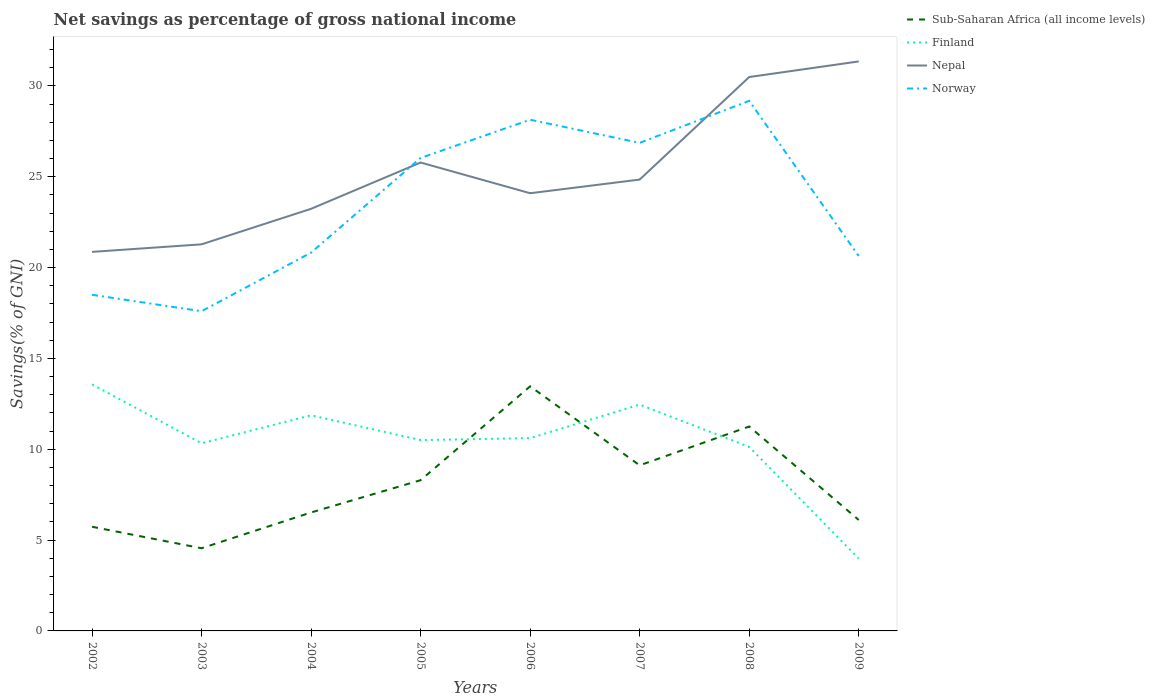Is the number of lines equal to the number of legend labels?
Your answer should be very brief. Yes. Across all years, what is the maximum total savings in Nepal?
Provide a short and direct response. 20.86. In which year was the total savings in Finland maximum?
Offer a very short reply. 2009. What is the total total savings in Nepal in the graph?
Offer a very short reply. -5.64. What is the difference between the highest and the second highest total savings in Finland?
Your response must be concise. 9.59. Is the total savings in Finland strictly greater than the total savings in Nepal over the years?
Provide a succinct answer. Yes. How many lines are there?
Your response must be concise. 4. Are the values on the major ticks of Y-axis written in scientific E-notation?
Offer a terse response. No. How many legend labels are there?
Provide a succinct answer. 4. How are the legend labels stacked?
Your response must be concise. Vertical. What is the title of the graph?
Give a very brief answer. Net savings as percentage of gross national income. What is the label or title of the X-axis?
Ensure brevity in your answer.  Years. What is the label or title of the Y-axis?
Offer a terse response. Savings(% of GNI). What is the Savings(% of GNI) in Sub-Saharan Africa (all income levels) in 2002?
Keep it short and to the point. 5.73. What is the Savings(% of GNI) in Finland in 2002?
Give a very brief answer. 13.57. What is the Savings(% of GNI) of Nepal in 2002?
Your response must be concise. 20.86. What is the Savings(% of GNI) of Norway in 2002?
Make the answer very short. 18.5. What is the Savings(% of GNI) of Sub-Saharan Africa (all income levels) in 2003?
Give a very brief answer. 4.55. What is the Savings(% of GNI) of Finland in 2003?
Offer a terse response. 10.33. What is the Savings(% of GNI) in Nepal in 2003?
Keep it short and to the point. 21.28. What is the Savings(% of GNI) of Norway in 2003?
Offer a very short reply. 17.6. What is the Savings(% of GNI) in Sub-Saharan Africa (all income levels) in 2004?
Ensure brevity in your answer.  6.52. What is the Savings(% of GNI) in Finland in 2004?
Ensure brevity in your answer.  11.87. What is the Savings(% of GNI) in Nepal in 2004?
Your response must be concise. 23.23. What is the Savings(% of GNI) of Norway in 2004?
Make the answer very short. 20.82. What is the Savings(% of GNI) of Sub-Saharan Africa (all income levels) in 2005?
Your answer should be compact. 8.3. What is the Savings(% of GNI) in Finland in 2005?
Offer a terse response. 10.5. What is the Savings(% of GNI) of Nepal in 2005?
Give a very brief answer. 25.78. What is the Savings(% of GNI) in Norway in 2005?
Your answer should be compact. 26.03. What is the Savings(% of GNI) of Sub-Saharan Africa (all income levels) in 2006?
Your response must be concise. 13.46. What is the Savings(% of GNI) in Finland in 2006?
Keep it short and to the point. 10.61. What is the Savings(% of GNI) in Nepal in 2006?
Offer a terse response. 24.09. What is the Savings(% of GNI) in Norway in 2006?
Provide a short and direct response. 28.14. What is the Savings(% of GNI) of Sub-Saharan Africa (all income levels) in 2007?
Your answer should be compact. 9.11. What is the Savings(% of GNI) in Finland in 2007?
Provide a succinct answer. 12.46. What is the Savings(% of GNI) of Nepal in 2007?
Keep it short and to the point. 24.84. What is the Savings(% of GNI) in Norway in 2007?
Ensure brevity in your answer.  26.86. What is the Savings(% of GNI) of Sub-Saharan Africa (all income levels) in 2008?
Offer a very short reply. 11.25. What is the Savings(% of GNI) in Finland in 2008?
Offer a terse response. 10.13. What is the Savings(% of GNI) in Nepal in 2008?
Offer a terse response. 30.49. What is the Savings(% of GNI) in Norway in 2008?
Your response must be concise. 29.18. What is the Savings(% of GNI) in Sub-Saharan Africa (all income levels) in 2009?
Make the answer very short. 6.11. What is the Savings(% of GNI) in Finland in 2009?
Provide a succinct answer. 3.99. What is the Savings(% of GNI) in Nepal in 2009?
Give a very brief answer. 31.35. What is the Savings(% of GNI) in Norway in 2009?
Provide a succinct answer. 20.64. Across all years, what is the maximum Savings(% of GNI) in Sub-Saharan Africa (all income levels)?
Your answer should be compact. 13.46. Across all years, what is the maximum Savings(% of GNI) in Finland?
Keep it short and to the point. 13.57. Across all years, what is the maximum Savings(% of GNI) of Nepal?
Offer a terse response. 31.35. Across all years, what is the maximum Savings(% of GNI) in Norway?
Make the answer very short. 29.18. Across all years, what is the minimum Savings(% of GNI) of Sub-Saharan Africa (all income levels)?
Give a very brief answer. 4.55. Across all years, what is the minimum Savings(% of GNI) of Finland?
Keep it short and to the point. 3.99. Across all years, what is the minimum Savings(% of GNI) in Nepal?
Ensure brevity in your answer.  20.86. Across all years, what is the minimum Savings(% of GNI) of Norway?
Keep it short and to the point. 17.6. What is the total Savings(% of GNI) in Sub-Saharan Africa (all income levels) in the graph?
Keep it short and to the point. 65.04. What is the total Savings(% of GNI) of Finland in the graph?
Your response must be concise. 83.46. What is the total Savings(% of GNI) of Nepal in the graph?
Your answer should be compact. 201.93. What is the total Savings(% of GNI) in Norway in the graph?
Your answer should be very brief. 187.77. What is the difference between the Savings(% of GNI) of Sub-Saharan Africa (all income levels) in 2002 and that in 2003?
Your answer should be compact. 1.18. What is the difference between the Savings(% of GNI) in Finland in 2002 and that in 2003?
Provide a succinct answer. 3.24. What is the difference between the Savings(% of GNI) of Nepal in 2002 and that in 2003?
Your response must be concise. -0.42. What is the difference between the Savings(% of GNI) in Norway in 2002 and that in 2003?
Offer a terse response. 0.9. What is the difference between the Savings(% of GNI) of Sub-Saharan Africa (all income levels) in 2002 and that in 2004?
Provide a succinct answer. -0.79. What is the difference between the Savings(% of GNI) of Finland in 2002 and that in 2004?
Offer a terse response. 1.7. What is the difference between the Savings(% of GNI) in Nepal in 2002 and that in 2004?
Give a very brief answer. -2.37. What is the difference between the Savings(% of GNI) in Norway in 2002 and that in 2004?
Ensure brevity in your answer.  -2.32. What is the difference between the Savings(% of GNI) in Sub-Saharan Africa (all income levels) in 2002 and that in 2005?
Give a very brief answer. -2.56. What is the difference between the Savings(% of GNI) in Finland in 2002 and that in 2005?
Keep it short and to the point. 3.07. What is the difference between the Savings(% of GNI) of Nepal in 2002 and that in 2005?
Offer a very short reply. -4.92. What is the difference between the Savings(% of GNI) in Norway in 2002 and that in 2005?
Make the answer very short. -7.53. What is the difference between the Savings(% of GNI) of Sub-Saharan Africa (all income levels) in 2002 and that in 2006?
Your answer should be very brief. -7.73. What is the difference between the Savings(% of GNI) in Finland in 2002 and that in 2006?
Offer a terse response. 2.96. What is the difference between the Savings(% of GNI) in Nepal in 2002 and that in 2006?
Ensure brevity in your answer.  -3.23. What is the difference between the Savings(% of GNI) in Norway in 2002 and that in 2006?
Keep it short and to the point. -9.64. What is the difference between the Savings(% of GNI) in Sub-Saharan Africa (all income levels) in 2002 and that in 2007?
Keep it short and to the point. -3.38. What is the difference between the Savings(% of GNI) of Finland in 2002 and that in 2007?
Offer a very short reply. 1.11. What is the difference between the Savings(% of GNI) of Nepal in 2002 and that in 2007?
Your response must be concise. -3.98. What is the difference between the Savings(% of GNI) in Norway in 2002 and that in 2007?
Your answer should be compact. -8.36. What is the difference between the Savings(% of GNI) of Sub-Saharan Africa (all income levels) in 2002 and that in 2008?
Your response must be concise. -5.52. What is the difference between the Savings(% of GNI) of Finland in 2002 and that in 2008?
Keep it short and to the point. 3.44. What is the difference between the Savings(% of GNI) in Nepal in 2002 and that in 2008?
Offer a very short reply. -9.62. What is the difference between the Savings(% of GNI) of Norway in 2002 and that in 2008?
Make the answer very short. -10.68. What is the difference between the Savings(% of GNI) in Sub-Saharan Africa (all income levels) in 2002 and that in 2009?
Give a very brief answer. -0.37. What is the difference between the Savings(% of GNI) of Finland in 2002 and that in 2009?
Make the answer very short. 9.59. What is the difference between the Savings(% of GNI) of Nepal in 2002 and that in 2009?
Your answer should be very brief. -10.48. What is the difference between the Savings(% of GNI) of Norway in 2002 and that in 2009?
Ensure brevity in your answer.  -2.14. What is the difference between the Savings(% of GNI) of Sub-Saharan Africa (all income levels) in 2003 and that in 2004?
Give a very brief answer. -1.97. What is the difference between the Savings(% of GNI) of Finland in 2003 and that in 2004?
Your answer should be very brief. -1.54. What is the difference between the Savings(% of GNI) of Nepal in 2003 and that in 2004?
Provide a short and direct response. -1.96. What is the difference between the Savings(% of GNI) in Norway in 2003 and that in 2004?
Your answer should be very brief. -3.23. What is the difference between the Savings(% of GNI) in Sub-Saharan Africa (all income levels) in 2003 and that in 2005?
Ensure brevity in your answer.  -3.75. What is the difference between the Savings(% of GNI) of Finland in 2003 and that in 2005?
Keep it short and to the point. -0.18. What is the difference between the Savings(% of GNI) of Nepal in 2003 and that in 2005?
Make the answer very short. -4.5. What is the difference between the Savings(% of GNI) in Norway in 2003 and that in 2005?
Offer a very short reply. -8.44. What is the difference between the Savings(% of GNI) of Sub-Saharan Africa (all income levels) in 2003 and that in 2006?
Provide a short and direct response. -8.91. What is the difference between the Savings(% of GNI) of Finland in 2003 and that in 2006?
Your response must be concise. -0.29. What is the difference between the Savings(% of GNI) in Nepal in 2003 and that in 2006?
Provide a short and direct response. -2.81. What is the difference between the Savings(% of GNI) in Norway in 2003 and that in 2006?
Your response must be concise. -10.54. What is the difference between the Savings(% of GNI) of Sub-Saharan Africa (all income levels) in 2003 and that in 2007?
Your response must be concise. -4.56. What is the difference between the Savings(% of GNI) in Finland in 2003 and that in 2007?
Keep it short and to the point. -2.13. What is the difference between the Savings(% of GNI) of Nepal in 2003 and that in 2007?
Offer a terse response. -3.57. What is the difference between the Savings(% of GNI) of Norway in 2003 and that in 2007?
Give a very brief answer. -9.27. What is the difference between the Savings(% of GNI) in Sub-Saharan Africa (all income levels) in 2003 and that in 2008?
Offer a very short reply. -6.7. What is the difference between the Savings(% of GNI) of Finland in 2003 and that in 2008?
Ensure brevity in your answer.  0.2. What is the difference between the Savings(% of GNI) of Nepal in 2003 and that in 2008?
Offer a terse response. -9.21. What is the difference between the Savings(% of GNI) in Norway in 2003 and that in 2008?
Make the answer very short. -11.58. What is the difference between the Savings(% of GNI) in Sub-Saharan Africa (all income levels) in 2003 and that in 2009?
Provide a short and direct response. -1.56. What is the difference between the Savings(% of GNI) in Finland in 2003 and that in 2009?
Give a very brief answer. 6.34. What is the difference between the Savings(% of GNI) of Nepal in 2003 and that in 2009?
Make the answer very short. -10.07. What is the difference between the Savings(% of GNI) in Norway in 2003 and that in 2009?
Offer a very short reply. -3.04. What is the difference between the Savings(% of GNI) in Sub-Saharan Africa (all income levels) in 2004 and that in 2005?
Keep it short and to the point. -1.78. What is the difference between the Savings(% of GNI) in Finland in 2004 and that in 2005?
Offer a terse response. 1.36. What is the difference between the Savings(% of GNI) in Nepal in 2004 and that in 2005?
Offer a terse response. -2.55. What is the difference between the Savings(% of GNI) of Norway in 2004 and that in 2005?
Offer a very short reply. -5.21. What is the difference between the Savings(% of GNI) in Sub-Saharan Africa (all income levels) in 2004 and that in 2006?
Ensure brevity in your answer.  -6.94. What is the difference between the Savings(% of GNI) in Finland in 2004 and that in 2006?
Your response must be concise. 1.26. What is the difference between the Savings(% of GNI) in Nepal in 2004 and that in 2006?
Offer a terse response. -0.86. What is the difference between the Savings(% of GNI) in Norway in 2004 and that in 2006?
Offer a terse response. -7.31. What is the difference between the Savings(% of GNI) of Sub-Saharan Africa (all income levels) in 2004 and that in 2007?
Make the answer very short. -2.59. What is the difference between the Savings(% of GNI) of Finland in 2004 and that in 2007?
Provide a short and direct response. -0.59. What is the difference between the Savings(% of GNI) of Nepal in 2004 and that in 2007?
Ensure brevity in your answer.  -1.61. What is the difference between the Savings(% of GNI) of Norway in 2004 and that in 2007?
Offer a very short reply. -6.04. What is the difference between the Savings(% of GNI) in Sub-Saharan Africa (all income levels) in 2004 and that in 2008?
Offer a very short reply. -4.73. What is the difference between the Savings(% of GNI) in Finland in 2004 and that in 2008?
Make the answer very short. 1.74. What is the difference between the Savings(% of GNI) in Nepal in 2004 and that in 2008?
Offer a very short reply. -7.25. What is the difference between the Savings(% of GNI) in Norway in 2004 and that in 2008?
Your response must be concise. -8.36. What is the difference between the Savings(% of GNI) in Sub-Saharan Africa (all income levels) in 2004 and that in 2009?
Provide a succinct answer. 0.41. What is the difference between the Savings(% of GNI) of Finland in 2004 and that in 2009?
Ensure brevity in your answer.  7.88. What is the difference between the Savings(% of GNI) in Nepal in 2004 and that in 2009?
Your answer should be very brief. -8.11. What is the difference between the Savings(% of GNI) in Norway in 2004 and that in 2009?
Give a very brief answer. 0.19. What is the difference between the Savings(% of GNI) in Sub-Saharan Africa (all income levels) in 2005 and that in 2006?
Your response must be concise. -5.17. What is the difference between the Savings(% of GNI) of Finland in 2005 and that in 2006?
Provide a short and direct response. -0.11. What is the difference between the Savings(% of GNI) in Nepal in 2005 and that in 2006?
Your answer should be compact. 1.69. What is the difference between the Savings(% of GNI) of Norway in 2005 and that in 2006?
Keep it short and to the point. -2.1. What is the difference between the Savings(% of GNI) in Sub-Saharan Africa (all income levels) in 2005 and that in 2007?
Offer a terse response. -0.82. What is the difference between the Savings(% of GNI) in Finland in 2005 and that in 2007?
Your answer should be compact. -1.95. What is the difference between the Savings(% of GNI) of Nepal in 2005 and that in 2007?
Provide a succinct answer. 0.94. What is the difference between the Savings(% of GNI) of Norway in 2005 and that in 2007?
Offer a very short reply. -0.83. What is the difference between the Savings(% of GNI) of Sub-Saharan Africa (all income levels) in 2005 and that in 2008?
Offer a very short reply. -2.95. What is the difference between the Savings(% of GNI) in Finland in 2005 and that in 2008?
Your answer should be very brief. 0.38. What is the difference between the Savings(% of GNI) of Nepal in 2005 and that in 2008?
Provide a short and direct response. -4.71. What is the difference between the Savings(% of GNI) in Norway in 2005 and that in 2008?
Your response must be concise. -3.14. What is the difference between the Savings(% of GNI) of Sub-Saharan Africa (all income levels) in 2005 and that in 2009?
Keep it short and to the point. 2.19. What is the difference between the Savings(% of GNI) in Finland in 2005 and that in 2009?
Offer a very short reply. 6.52. What is the difference between the Savings(% of GNI) in Nepal in 2005 and that in 2009?
Your answer should be compact. -5.56. What is the difference between the Savings(% of GNI) in Norway in 2005 and that in 2009?
Give a very brief answer. 5.4. What is the difference between the Savings(% of GNI) of Sub-Saharan Africa (all income levels) in 2006 and that in 2007?
Keep it short and to the point. 4.35. What is the difference between the Savings(% of GNI) of Finland in 2006 and that in 2007?
Provide a short and direct response. -1.85. What is the difference between the Savings(% of GNI) of Nepal in 2006 and that in 2007?
Offer a terse response. -0.75. What is the difference between the Savings(% of GNI) of Norway in 2006 and that in 2007?
Make the answer very short. 1.27. What is the difference between the Savings(% of GNI) of Sub-Saharan Africa (all income levels) in 2006 and that in 2008?
Make the answer very short. 2.21. What is the difference between the Savings(% of GNI) of Finland in 2006 and that in 2008?
Keep it short and to the point. 0.48. What is the difference between the Savings(% of GNI) in Nepal in 2006 and that in 2008?
Make the answer very short. -6.4. What is the difference between the Savings(% of GNI) in Norway in 2006 and that in 2008?
Give a very brief answer. -1.04. What is the difference between the Savings(% of GNI) of Sub-Saharan Africa (all income levels) in 2006 and that in 2009?
Offer a terse response. 7.36. What is the difference between the Savings(% of GNI) of Finland in 2006 and that in 2009?
Give a very brief answer. 6.63. What is the difference between the Savings(% of GNI) of Nepal in 2006 and that in 2009?
Your answer should be compact. -7.25. What is the difference between the Savings(% of GNI) of Norway in 2006 and that in 2009?
Keep it short and to the point. 7.5. What is the difference between the Savings(% of GNI) in Sub-Saharan Africa (all income levels) in 2007 and that in 2008?
Offer a very short reply. -2.14. What is the difference between the Savings(% of GNI) in Finland in 2007 and that in 2008?
Your response must be concise. 2.33. What is the difference between the Savings(% of GNI) in Nepal in 2007 and that in 2008?
Your response must be concise. -5.64. What is the difference between the Savings(% of GNI) in Norway in 2007 and that in 2008?
Your answer should be very brief. -2.31. What is the difference between the Savings(% of GNI) of Sub-Saharan Africa (all income levels) in 2007 and that in 2009?
Your answer should be compact. 3.01. What is the difference between the Savings(% of GNI) in Finland in 2007 and that in 2009?
Give a very brief answer. 8.47. What is the difference between the Savings(% of GNI) of Nepal in 2007 and that in 2009?
Give a very brief answer. -6.5. What is the difference between the Savings(% of GNI) in Norway in 2007 and that in 2009?
Offer a very short reply. 6.23. What is the difference between the Savings(% of GNI) in Sub-Saharan Africa (all income levels) in 2008 and that in 2009?
Offer a terse response. 5.14. What is the difference between the Savings(% of GNI) in Finland in 2008 and that in 2009?
Ensure brevity in your answer.  6.14. What is the difference between the Savings(% of GNI) in Nepal in 2008 and that in 2009?
Make the answer very short. -0.86. What is the difference between the Savings(% of GNI) of Norway in 2008 and that in 2009?
Your answer should be very brief. 8.54. What is the difference between the Savings(% of GNI) in Sub-Saharan Africa (all income levels) in 2002 and the Savings(% of GNI) in Finland in 2003?
Offer a terse response. -4.59. What is the difference between the Savings(% of GNI) in Sub-Saharan Africa (all income levels) in 2002 and the Savings(% of GNI) in Nepal in 2003?
Your answer should be compact. -15.55. What is the difference between the Savings(% of GNI) in Sub-Saharan Africa (all income levels) in 2002 and the Savings(% of GNI) in Norway in 2003?
Give a very brief answer. -11.86. What is the difference between the Savings(% of GNI) of Finland in 2002 and the Savings(% of GNI) of Nepal in 2003?
Keep it short and to the point. -7.71. What is the difference between the Savings(% of GNI) in Finland in 2002 and the Savings(% of GNI) in Norway in 2003?
Your response must be concise. -4.03. What is the difference between the Savings(% of GNI) of Nepal in 2002 and the Savings(% of GNI) of Norway in 2003?
Ensure brevity in your answer.  3.27. What is the difference between the Savings(% of GNI) in Sub-Saharan Africa (all income levels) in 2002 and the Savings(% of GNI) in Finland in 2004?
Your answer should be very brief. -6.14. What is the difference between the Savings(% of GNI) in Sub-Saharan Africa (all income levels) in 2002 and the Savings(% of GNI) in Nepal in 2004?
Your answer should be compact. -17.5. What is the difference between the Savings(% of GNI) of Sub-Saharan Africa (all income levels) in 2002 and the Savings(% of GNI) of Norway in 2004?
Your answer should be compact. -15.09. What is the difference between the Savings(% of GNI) in Finland in 2002 and the Savings(% of GNI) in Nepal in 2004?
Offer a very short reply. -9.66. What is the difference between the Savings(% of GNI) of Finland in 2002 and the Savings(% of GNI) of Norway in 2004?
Provide a succinct answer. -7.25. What is the difference between the Savings(% of GNI) in Nepal in 2002 and the Savings(% of GNI) in Norway in 2004?
Your answer should be very brief. 0.04. What is the difference between the Savings(% of GNI) of Sub-Saharan Africa (all income levels) in 2002 and the Savings(% of GNI) of Finland in 2005?
Your answer should be compact. -4.77. What is the difference between the Savings(% of GNI) of Sub-Saharan Africa (all income levels) in 2002 and the Savings(% of GNI) of Nepal in 2005?
Give a very brief answer. -20.05. What is the difference between the Savings(% of GNI) in Sub-Saharan Africa (all income levels) in 2002 and the Savings(% of GNI) in Norway in 2005?
Give a very brief answer. -20.3. What is the difference between the Savings(% of GNI) in Finland in 2002 and the Savings(% of GNI) in Nepal in 2005?
Make the answer very short. -12.21. What is the difference between the Savings(% of GNI) of Finland in 2002 and the Savings(% of GNI) of Norway in 2005?
Make the answer very short. -12.46. What is the difference between the Savings(% of GNI) in Nepal in 2002 and the Savings(% of GNI) in Norway in 2005?
Your answer should be very brief. -5.17. What is the difference between the Savings(% of GNI) in Sub-Saharan Africa (all income levels) in 2002 and the Savings(% of GNI) in Finland in 2006?
Offer a very short reply. -4.88. What is the difference between the Savings(% of GNI) of Sub-Saharan Africa (all income levels) in 2002 and the Savings(% of GNI) of Nepal in 2006?
Keep it short and to the point. -18.36. What is the difference between the Savings(% of GNI) in Sub-Saharan Africa (all income levels) in 2002 and the Savings(% of GNI) in Norway in 2006?
Give a very brief answer. -22.4. What is the difference between the Savings(% of GNI) in Finland in 2002 and the Savings(% of GNI) in Nepal in 2006?
Offer a very short reply. -10.52. What is the difference between the Savings(% of GNI) in Finland in 2002 and the Savings(% of GNI) in Norway in 2006?
Your answer should be compact. -14.57. What is the difference between the Savings(% of GNI) in Nepal in 2002 and the Savings(% of GNI) in Norway in 2006?
Offer a terse response. -7.27. What is the difference between the Savings(% of GNI) of Sub-Saharan Africa (all income levels) in 2002 and the Savings(% of GNI) of Finland in 2007?
Your answer should be compact. -6.73. What is the difference between the Savings(% of GNI) of Sub-Saharan Africa (all income levels) in 2002 and the Savings(% of GNI) of Nepal in 2007?
Keep it short and to the point. -19.11. What is the difference between the Savings(% of GNI) of Sub-Saharan Africa (all income levels) in 2002 and the Savings(% of GNI) of Norway in 2007?
Your answer should be compact. -21.13. What is the difference between the Savings(% of GNI) in Finland in 2002 and the Savings(% of GNI) in Nepal in 2007?
Ensure brevity in your answer.  -11.27. What is the difference between the Savings(% of GNI) of Finland in 2002 and the Savings(% of GNI) of Norway in 2007?
Offer a very short reply. -13.29. What is the difference between the Savings(% of GNI) of Nepal in 2002 and the Savings(% of GNI) of Norway in 2007?
Offer a very short reply. -6. What is the difference between the Savings(% of GNI) in Sub-Saharan Africa (all income levels) in 2002 and the Savings(% of GNI) in Finland in 2008?
Your answer should be compact. -4.4. What is the difference between the Savings(% of GNI) of Sub-Saharan Africa (all income levels) in 2002 and the Savings(% of GNI) of Nepal in 2008?
Give a very brief answer. -24.76. What is the difference between the Savings(% of GNI) of Sub-Saharan Africa (all income levels) in 2002 and the Savings(% of GNI) of Norway in 2008?
Provide a succinct answer. -23.45. What is the difference between the Savings(% of GNI) of Finland in 2002 and the Savings(% of GNI) of Nepal in 2008?
Make the answer very short. -16.92. What is the difference between the Savings(% of GNI) in Finland in 2002 and the Savings(% of GNI) in Norway in 2008?
Provide a short and direct response. -15.61. What is the difference between the Savings(% of GNI) in Nepal in 2002 and the Savings(% of GNI) in Norway in 2008?
Offer a terse response. -8.32. What is the difference between the Savings(% of GNI) of Sub-Saharan Africa (all income levels) in 2002 and the Savings(% of GNI) of Finland in 2009?
Your answer should be very brief. 1.75. What is the difference between the Savings(% of GNI) of Sub-Saharan Africa (all income levels) in 2002 and the Savings(% of GNI) of Nepal in 2009?
Your answer should be very brief. -25.61. What is the difference between the Savings(% of GNI) in Sub-Saharan Africa (all income levels) in 2002 and the Savings(% of GNI) in Norway in 2009?
Make the answer very short. -14.9. What is the difference between the Savings(% of GNI) in Finland in 2002 and the Savings(% of GNI) in Nepal in 2009?
Make the answer very short. -17.78. What is the difference between the Savings(% of GNI) in Finland in 2002 and the Savings(% of GNI) in Norway in 2009?
Offer a terse response. -7.07. What is the difference between the Savings(% of GNI) of Nepal in 2002 and the Savings(% of GNI) of Norway in 2009?
Offer a terse response. 0.23. What is the difference between the Savings(% of GNI) of Sub-Saharan Africa (all income levels) in 2003 and the Savings(% of GNI) of Finland in 2004?
Provide a succinct answer. -7.32. What is the difference between the Savings(% of GNI) in Sub-Saharan Africa (all income levels) in 2003 and the Savings(% of GNI) in Nepal in 2004?
Your answer should be compact. -18.68. What is the difference between the Savings(% of GNI) of Sub-Saharan Africa (all income levels) in 2003 and the Savings(% of GNI) of Norway in 2004?
Your answer should be very brief. -16.27. What is the difference between the Savings(% of GNI) in Finland in 2003 and the Savings(% of GNI) in Nepal in 2004?
Your answer should be very brief. -12.91. What is the difference between the Savings(% of GNI) of Finland in 2003 and the Savings(% of GNI) of Norway in 2004?
Give a very brief answer. -10.5. What is the difference between the Savings(% of GNI) of Nepal in 2003 and the Savings(% of GNI) of Norway in 2004?
Offer a terse response. 0.46. What is the difference between the Savings(% of GNI) in Sub-Saharan Africa (all income levels) in 2003 and the Savings(% of GNI) in Finland in 2005?
Your answer should be compact. -5.95. What is the difference between the Savings(% of GNI) of Sub-Saharan Africa (all income levels) in 2003 and the Savings(% of GNI) of Nepal in 2005?
Ensure brevity in your answer.  -21.23. What is the difference between the Savings(% of GNI) in Sub-Saharan Africa (all income levels) in 2003 and the Savings(% of GNI) in Norway in 2005?
Ensure brevity in your answer.  -21.48. What is the difference between the Savings(% of GNI) of Finland in 2003 and the Savings(% of GNI) of Nepal in 2005?
Give a very brief answer. -15.45. What is the difference between the Savings(% of GNI) of Finland in 2003 and the Savings(% of GNI) of Norway in 2005?
Make the answer very short. -15.71. What is the difference between the Savings(% of GNI) of Nepal in 2003 and the Savings(% of GNI) of Norway in 2005?
Offer a very short reply. -4.76. What is the difference between the Savings(% of GNI) in Sub-Saharan Africa (all income levels) in 2003 and the Savings(% of GNI) in Finland in 2006?
Provide a short and direct response. -6.06. What is the difference between the Savings(% of GNI) in Sub-Saharan Africa (all income levels) in 2003 and the Savings(% of GNI) in Nepal in 2006?
Make the answer very short. -19.54. What is the difference between the Savings(% of GNI) in Sub-Saharan Africa (all income levels) in 2003 and the Savings(% of GNI) in Norway in 2006?
Make the answer very short. -23.59. What is the difference between the Savings(% of GNI) in Finland in 2003 and the Savings(% of GNI) in Nepal in 2006?
Your answer should be compact. -13.77. What is the difference between the Savings(% of GNI) in Finland in 2003 and the Savings(% of GNI) in Norway in 2006?
Offer a very short reply. -17.81. What is the difference between the Savings(% of GNI) in Nepal in 2003 and the Savings(% of GNI) in Norway in 2006?
Provide a succinct answer. -6.86. What is the difference between the Savings(% of GNI) of Sub-Saharan Africa (all income levels) in 2003 and the Savings(% of GNI) of Finland in 2007?
Offer a very short reply. -7.91. What is the difference between the Savings(% of GNI) in Sub-Saharan Africa (all income levels) in 2003 and the Savings(% of GNI) in Nepal in 2007?
Ensure brevity in your answer.  -20.29. What is the difference between the Savings(% of GNI) in Sub-Saharan Africa (all income levels) in 2003 and the Savings(% of GNI) in Norway in 2007?
Make the answer very short. -22.31. What is the difference between the Savings(% of GNI) of Finland in 2003 and the Savings(% of GNI) of Nepal in 2007?
Provide a short and direct response. -14.52. What is the difference between the Savings(% of GNI) of Finland in 2003 and the Savings(% of GNI) of Norway in 2007?
Offer a terse response. -16.54. What is the difference between the Savings(% of GNI) in Nepal in 2003 and the Savings(% of GNI) in Norway in 2007?
Make the answer very short. -5.59. What is the difference between the Savings(% of GNI) of Sub-Saharan Africa (all income levels) in 2003 and the Savings(% of GNI) of Finland in 2008?
Offer a terse response. -5.58. What is the difference between the Savings(% of GNI) in Sub-Saharan Africa (all income levels) in 2003 and the Savings(% of GNI) in Nepal in 2008?
Provide a succinct answer. -25.94. What is the difference between the Savings(% of GNI) of Sub-Saharan Africa (all income levels) in 2003 and the Savings(% of GNI) of Norway in 2008?
Make the answer very short. -24.63. What is the difference between the Savings(% of GNI) of Finland in 2003 and the Savings(% of GNI) of Nepal in 2008?
Your answer should be compact. -20.16. What is the difference between the Savings(% of GNI) of Finland in 2003 and the Savings(% of GNI) of Norway in 2008?
Give a very brief answer. -18.85. What is the difference between the Savings(% of GNI) of Nepal in 2003 and the Savings(% of GNI) of Norway in 2008?
Ensure brevity in your answer.  -7.9. What is the difference between the Savings(% of GNI) of Sub-Saharan Africa (all income levels) in 2003 and the Savings(% of GNI) of Finland in 2009?
Offer a terse response. 0.57. What is the difference between the Savings(% of GNI) in Sub-Saharan Africa (all income levels) in 2003 and the Savings(% of GNI) in Nepal in 2009?
Give a very brief answer. -26.8. What is the difference between the Savings(% of GNI) of Sub-Saharan Africa (all income levels) in 2003 and the Savings(% of GNI) of Norway in 2009?
Offer a very short reply. -16.09. What is the difference between the Savings(% of GNI) of Finland in 2003 and the Savings(% of GNI) of Nepal in 2009?
Offer a very short reply. -21.02. What is the difference between the Savings(% of GNI) of Finland in 2003 and the Savings(% of GNI) of Norway in 2009?
Your response must be concise. -10.31. What is the difference between the Savings(% of GNI) in Nepal in 2003 and the Savings(% of GNI) in Norway in 2009?
Give a very brief answer. 0.64. What is the difference between the Savings(% of GNI) of Sub-Saharan Africa (all income levels) in 2004 and the Savings(% of GNI) of Finland in 2005?
Provide a succinct answer. -3.98. What is the difference between the Savings(% of GNI) of Sub-Saharan Africa (all income levels) in 2004 and the Savings(% of GNI) of Nepal in 2005?
Your response must be concise. -19.26. What is the difference between the Savings(% of GNI) of Sub-Saharan Africa (all income levels) in 2004 and the Savings(% of GNI) of Norway in 2005?
Provide a short and direct response. -19.51. What is the difference between the Savings(% of GNI) of Finland in 2004 and the Savings(% of GNI) of Nepal in 2005?
Your answer should be compact. -13.91. What is the difference between the Savings(% of GNI) of Finland in 2004 and the Savings(% of GNI) of Norway in 2005?
Offer a terse response. -14.16. What is the difference between the Savings(% of GNI) of Nepal in 2004 and the Savings(% of GNI) of Norway in 2005?
Offer a terse response. -2.8. What is the difference between the Savings(% of GNI) in Sub-Saharan Africa (all income levels) in 2004 and the Savings(% of GNI) in Finland in 2006?
Your response must be concise. -4.09. What is the difference between the Savings(% of GNI) in Sub-Saharan Africa (all income levels) in 2004 and the Savings(% of GNI) in Nepal in 2006?
Provide a succinct answer. -17.57. What is the difference between the Savings(% of GNI) in Sub-Saharan Africa (all income levels) in 2004 and the Savings(% of GNI) in Norway in 2006?
Ensure brevity in your answer.  -21.62. What is the difference between the Savings(% of GNI) in Finland in 2004 and the Savings(% of GNI) in Nepal in 2006?
Your answer should be compact. -12.22. What is the difference between the Savings(% of GNI) in Finland in 2004 and the Savings(% of GNI) in Norway in 2006?
Provide a succinct answer. -16.27. What is the difference between the Savings(% of GNI) of Nepal in 2004 and the Savings(% of GNI) of Norway in 2006?
Offer a very short reply. -4.9. What is the difference between the Savings(% of GNI) in Sub-Saharan Africa (all income levels) in 2004 and the Savings(% of GNI) in Finland in 2007?
Your answer should be very brief. -5.94. What is the difference between the Savings(% of GNI) of Sub-Saharan Africa (all income levels) in 2004 and the Savings(% of GNI) of Nepal in 2007?
Keep it short and to the point. -18.32. What is the difference between the Savings(% of GNI) in Sub-Saharan Africa (all income levels) in 2004 and the Savings(% of GNI) in Norway in 2007?
Offer a very short reply. -20.34. What is the difference between the Savings(% of GNI) in Finland in 2004 and the Savings(% of GNI) in Nepal in 2007?
Give a very brief answer. -12.97. What is the difference between the Savings(% of GNI) in Finland in 2004 and the Savings(% of GNI) in Norway in 2007?
Offer a very short reply. -14.99. What is the difference between the Savings(% of GNI) of Nepal in 2004 and the Savings(% of GNI) of Norway in 2007?
Ensure brevity in your answer.  -3.63. What is the difference between the Savings(% of GNI) in Sub-Saharan Africa (all income levels) in 2004 and the Savings(% of GNI) in Finland in 2008?
Offer a terse response. -3.61. What is the difference between the Savings(% of GNI) of Sub-Saharan Africa (all income levels) in 2004 and the Savings(% of GNI) of Nepal in 2008?
Keep it short and to the point. -23.97. What is the difference between the Savings(% of GNI) in Sub-Saharan Africa (all income levels) in 2004 and the Savings(% of GNI) in Norway in 2008?
Offer a terse response. -22.66. What is the difference between the Savings(% of GNI) in Finland in 2004 and the Savings(% of GNI) in Nepal in 2008?
Your answer should be compact. -18.62. What is the difference between the Savings(% of GNI) in Finland in 2004 and the Savings(% of GNI) in Norway in 2008?
Offer a very short reply. -17.31. What is the difference between the Savings(% of GNI) in Nepal in 2004 and the Savings(% of GNI) in Norway in 2008?
Your response must be concise. -5.94. What is the difference between the Savings(% of GNI) of Sub-Saharan Africa (all income levels) in 2004 and the Savings(% of GNI) of Finland in 2009?
Provide a succinct answer. 2.54. What is the difference between the Savings(% of GNI) of Sub-Saharan Africa (all income levels) in 2004 and the Savings(% of GNI) of Nepal in 2009?
Offer a very short reply. -24.83. What is the difference between the Savings(% of GNI) of Sub-Saharan Africa (all income levels) in 2004 and the Savings(% of GNI) of Norway in 2009?
Make the answer very short. -14.12. What is the difference between the Savings(% of GNI) of Finland in 2004 and the Savings(% of GNI) of Nepal in 2009?
Provide a short and direct response. -19.48. What is the difference between the Savings(% of GNI) in Finland in 2004 and the Savings(% of GNI) in Norway in 2009?
Your answer should be very brief. -8.77. What is the difference between the Savings(% of GNI) of Nepal in 2004 and the Savings(% of GNI) of Norway in 2009?
Provide a succinct answer. 2.6. What is the difference between the Savings(% of GNI) of Sub-Saharan Africa (all income levels) in 2005 and the Savings(% of GNI) of Finland in 2006?
Your answer should be compact. -2.32. What is the difference between the Savings(% of GNI) in Sub-Saharan Africa (all income levels) in 2005 and the Savings(% of GNI) in Nepal in 2006?
Offer a very short reply. -15.8. What is the difference between the Savings(% of GNI) in Sub-Saharan Africa (all income levels) in 2005 and the Savings(% of GNI) in Norway in 2006?
Your answer should be compact. -19.84. What is the difference between the Savings(% of GNI) in Finland in 2005 and the Savings(% of GNI) in Nepal in 2006?
Your answer should be compact. -13.59. What is the difference between the Savings(% of GNI) in Finland in 2005 and the Savings(% of GNI) in Norway in 2006?
Your answer should be compact. -17.63. What is the difference between the Savings(% of GNI) in Nepal in 2005 and the Savings(% of GNI) in Norway in 2006?
Offer a very short reply. -2.36. What is the difference between the Savings(% of GNI) of Sub-Saharan Africa (all income levels) in 2005 and the Savings(% of GNI) of Finland in 2007?
Keep it short and to the point. -4.16. What is the difference between the Savings(% of GNI) in Sub-Saharan Africa (all income levels) in 2005 and the Savings(% of GNI) in Nepal in 2007?
Your response must be concise. -16.55. What is the difference between the Savings(% of GNI) of Sub-Saharan Africa (all income levels) in 2005 and the Savings(% of GNI) of Norway in 2007?
Keep it short and to the point. -18.57. What is the difference between the Savings(% of GNI) of Finland in 2005 and the Savings(% of GNI) of Nepal in 2007?
Provide a succinct answer. -14.34. What is the difference between the Savings(% of GNI) in Finland in 2005 and the Savings(% of GNI) in Norway in 2007?
Offer a very short reply. -16.36. What is the difference between the Savings(% of GNI) of Nepal in 2005 and the Savings(% of GNI) of Norway in 2007?
Make the answer very short. -1.08. What is the difference between the Savings(% of GNI) in Sub-Saharan Africa (all income levels) in 2005 and the Savings(% of GNI) in Finland in 2008?
Your answer should be very brief. -1.83. What is the difference between the Savings(% of GNI) of Sub-Saharan Africa (all income levels) in 2005 and the Savings(% of GNI) of Nepal in 2008?
Provide a succinct answer. -22.19. What is the difference between the Savings(% of GNI) of Sub-Saharan Africa (all income levels) in 2005 and the Savings(% of GNI) of Norway in 2008?
Keep it short and to the point. -20.88. What is the difference between the Savings(% of GNI) of Finland in 2005 and the Savings(% of GNI) of Nepal in 2008?
Your answer should be very brief. -19.98. What is the difference between the Savings(% of GNI) of Finland in 2005 and the Savings(% of GNI) of Norway in 2008?
Ensure brevity in your answer.  -18.67. What is the difference between the Savings(% of GNI) in Nepal in 2005 and the Savings(% of GNI) in Norway in 2008?
Give a very brief answer. -3.4. What is the difference between the Savings(% of GNI) of Sub-Saharan Africa (all income levels) in 2005 and the Savings(% of GNI) of Finland in 2009?
Your answer should be compact. 4.31. What is the difference between the Savings(% of GNI) of Sub-Saharan Africa (all income levels) in 2005 and the Savings(% of GNI) of Nepal in 2009?
Provide a succinct answer. -23.05. What is the difference between the Savings(% of GNI) in Sub-Saharan Africa (all income levels) in 2005 and the Savings(% of GNI) in Norway in 2009?
Provide a succinct answer. -12.34. What is the difference between the Savings(% of GNI) of Finland in 2005 and the Savings(% of GNI) of Nepal in 2009?
Offer a terse response. -20.84. What is the difference between the Savings(% of GNI) of Finland in 2005 and the Savings(% of GNI) of Norway in 2009?
Your response must be concise. -10.13. What is the difference between the Savings(% of GNI) in Nepal in 2005 and the Savings(% of GNI) in Norway in 2009?
Your answer should be very brief. 5.14. What is the difference between the Savings(% of GNI) of Sub-Saharan Africa (all income levels) in 2006 and the Savings(% of GNI) of Nepal in 2007?
Your answer should be compact. -11.38. What is the difference between the Savings(% of GNI) in Sub-Saharan Africa (all income levels) in 2006 and the Savings(% of GNI) in Norway in 2007?
Make the answer very short. -13.4. What is the difference between the Savings(% of GNI) in Finland in 2006 and the Savings(% of GNI) in Nepal in 2007?
Your response must be concise. -14.23. What is the difference between the Savings(% of GNI) in Finland in 2006 and the Savings(% of GNI) in Norway in 2007?
Your response must be concise. -16.25. What is the difference between the Savings(% of GNI) in Nepal in 2006 and the Savings(% of GNI) in Norway in 2007?
Give a very brief answer. -2.77. What is the difference between the Savings(% of GNI) of Sub-Saharan Africa (all income levels) in 2006 and the Savings(% of GNI) of Finland in 2008?
Make the answer very short. 3.33. What is the difference between the Savings(% of GNI) of Sub-Saharan Africa (all income levels) in 2006 and the Savings(% of GNI) of Nepal in 2008?
Your answer should be compact. -17.03. What is the difference between the Savings(% of GNI) in Sub-Saharan Africa (all income levels) in 2006 and the Savings(% of GNI) in Norway in 2008?
Ensure brevity in your answer.  -15.72. What is the difference between the Savings(% of GNI) in Finland in 2006 and the Savings(% of GNI) in Nepal in 2008?
Offer a very short reply. -19.88. What is the difference between the Savings(% of GNI) of Finland in 2006 and the Savings(% of GNI) of Norway in 2008?
Offer a very short reply. -18.57. What is the difference between the Savings(% of GNI) of Nepal in 2006 and the Savings(% of GNI) of Norway in 2008?
Give a very brief answer. -5.09. What is the difference between the Savings(% of GNI) of Sub-Saharan Africa (all income levels) in 2006 and the Savings(% of GNI) of Finland in 2009?
Give a very brief answer. 9.48. What is the difference between the Savings(% of GNI) of Sub-Saharan Africa (all income levels) in 2006 and the Savings(% of GNI) of Nepal in 2009?
Give a very brief answer. -17.88. What is the difference between the Savings(% of GNI) of Sub-Saharan Africa (all income levels) in 2006 and the Savings(% of GNI) of Norway in 2009?
Ensure brevity in your answer.  -7.17. What is the difference between the Savings(% of GNI) in Finland in 2006 and the Savings(% of GNI) in Nepal in 2009?
Your response must be concise. -20.73. What is the difference between the Savings(% of GNI) in Finland in 2006 and the Savings(% of GNI) in Norway in 2009?
Keep it short and to the point. -10.02. What is the difference between the Savings(% of GNI) of Nepal in 2006 and the Savings(% of GNI) of Norway in 2009?
Your response must be concise. 3.45. What is the difference between the Savings(% of GNI) of Sub-Saharan Africa (all income levels) in 2007 and the Savings(% of GNI) of Finland in 2008?
Ensure brevity in your answer.  -1.01. What is the difference between the Savings(% of GNI) of Sub-Saharan Africa (all income levels) in 2007 and the Savings(% of GNI) of Nepal in 2008?
Make the answer very short. -21.37. What is the difference between the Savings(% of GNI) in Sub-Saharan Africa (all income levels) in 2007 and the Savings(% of GNI) in Norway in 2008?
Make the answer very short. -20.06. What is the difference between the Savings(% of GNI) in Finland in 2007 and the Savings(% of GNI) in Nepal in 2008?
Provide a succinct answer. -18.03. What is the difference between the Savings(% of GNI) in Finland in 2007 and the Savings(% of GNI) in Norway in 2008?
Your answer should be very brief. -16.72. What is the difference between the Savings(% of GNI) in Nepal in 2007 and the Savings(% of GNI) in Norway in 2008?
Your answer should be very brief. -4.33. What is the difference between the Savings(% of GNI) in Sub-Saharan Africa (all income levels) in 2007 and the Savings(% of GNI) in Finland in 2009?
Your answer should be compact. 5.13. What is the difference between the Savings(% of GNI) in Sub-Saharan Africa (all income levels) in 2007 and the Savings(% of GNI) in Nepal in 2009?
Make the answer very short. -22.23. What is the difference between the Savings(% of GNI) in Sub-Saharan Africa (all income levels) in 2007 and the Savings(% of GNI) in Norway in 2009?
Your response must be concise. -11.52. What is the difference between the Savings(% of GNI) of Finland in 2007 and the Savings(% of GNI) of Nepal in 2009?
Give a very brief answer. -18.89. What is the difference between the Savings(% of GNI) in Finland in 2007 and the Savings(% of GNI) in Norway in 2009?
Keep it short and to the point. -8.18. What is the difference between the Savings(% of GNI) in Nepal in 2007 and the Savings(% of GNI) in Norway in 2009?
Offer a terse response. 4.21. What is the difference between the Savings(% of GNI) in Sub-Saharan Africa (all income levels) in 2008 and the Savings(% of GNI) in Finland in 2009?
Ensure brevity in your answer.  7.27. What is the difference between the Savings(% of GNI) of Sub-Saharan Africa (all income levels) in 2008 and the Savings(% of GNI) of Nepal in 2009?
Your answer should be very brief. -20.09. What is the difference between the Savings(% of GNI) in Sub-Saharan Africa (all income levels) in 2008 and the Savings(% of GNI) in Norway in 2009?
Ensure brevity in your answer.  -9.39. What is the difference between the Savings(% of GNI) of Finland in 2008 and the Savings(% of GNI) of Nepal in 2009?
Keep it short and to the point. -21.22. What is the difference between the Savings(% of GNI) of Finland in 2008 and the Savings(% of GNI) of Norway in 2009?
Keep it short and to the point. -10.51. What is the difference between the Savings(% of GNI) of Nepal in 2008 and the Savings(% of GNI) of Norway in 2009?
Provide a short and direct response. 9.85. What is the average Savings(% of GNI) of Sub-Saharan Africa (all income levels) per year?
Ensure brevity in your answer.  8.13. What is the average Savings(% of GNI) of Finland per year?
Offer a very short reply. 10.43. What is the average Savings(% of GNI) in Nepal per year?
Ensure brevity in your answer.  25.24. What is the average Savings(% of GNI) in Norway per year?
Provide a short and direct response. 23.47. In the year 2002, what is the difference between the Savings(% of GNI) in Sub-Saharan Africa (all income levels) and Savings(% of GNI) in Finland?
Your answer should be compact. -7.84. In the year 2002, what is the difference between the Savings(% of GNI) of Sub-Saharan Africa (all income levels) and Savings(% of GNI) of Nepal?
Offer a very short reply. -15.13. In the year 2002, what is the difference between the Savings(% of GNI) in Sub-Saharan Africa (all income levels) and Savings(% of GNI) in Norway?
Give a very brief answer. -12.77. In the year 2002, what is the difference between the Savings(% of GNI) in Finland and Savings(% of GNI) in Nepal?
Provide a succinct answer. -7.29. In the year 2002, what is the difference between the Savings(% of GNI) of Finland and Savings(% of GNI) of Norway?
Provide a short and direct response. -4.93. In the year 2002, what is the difference between the Savings(% of GNI) in Nepal and Savings(% of GNI) in Norway?
Your answer should be compact. 2.36. In the year 2003, what is the difference between the Savings(% of GNI) in Sub-Saharan Africa (all income levels) and Savings(% of GNI) in Finland?
Provide a succinct answer. -5.78. In the year 2003, what is the difference between the Savings(% of GNI) of Sub-Saharan Africa (all income levels) and Savings(% of GNI) of Nepal?
Your response must be concise. -16.73. In the year 2003, what is the difference between the Savings(% of GNI) in Sub-Saharan Africa (all income levels) and Savings(% of GNI) in Norway?
Offer a terse response. -13.05. In the year 2003, what is the difference between the Savings(% of GNI) in Finland and Savings(% of GNI) in Nepal?
Your response must be concise. -10.95. In the year 2003, what is the difference between the Savings(% of GNI) of Finland and Savings(% of GNI) of Norway?
Make the answer very short. -7.27. In the year 2003, what is the difference between the Savings(% of GNI) of Nepal and Savings(% of GNI) of Norway?
Offer a terse response. 3.68. In the year 2004, what is the difference between the Savings(% of GNI) in Sub-Saharan Africa (all income levels) and Savings(% of GNI) in Finland?
Your answer should be compact. -5.35. In the year 2004, what is the difference between the Savings(% of GNI) in Sub-Saharan Africa (all income levels) and Savings(% of GNI) in Nepal?
Make the answer very short. -16.71. In the year 2004, what is the difference between the Savings(% of GNI) in Sub-Saharan Africa (all income levels) and Savings(% of GNI) in Norway?
Your answer should be compact. -14.3. In the year 2004, what is the difference between the Savings(% of GNI) in Finland and Savings(% of GNI) in Nepal?
Keep it short and to the point. -11.36. In the year 2004, what is the difference between the Savings(% of GNI) of Finland and Savings(% of GNI) of Norway?
Provide a succinct answer. -8.95. In the year 2004, what is the difference between the Savings(% of GNI) in Nepal and Savings(% of GNI) in Norway?
Give a very brief answer. 2.41. In the year 2005, what is the difference between the Savings(% of GNI) of Sub-Saharan Africa (all income levels) and Savings(% of GNI) of Finland?
Offer a terse response. -2.21. In the year 2005, what is the difference between the Savings(% of GNI) in Sub-Saharan Africa (all income levels) and Savings(% of GNI) in Nepal?
Make the answer very short. -17.48. In the year 2005, what is the difference between the Savings(% of GNI) in Sub-Saharan Africa (all income levels) and Savings(% of GNI) in Norway?
Provide a succinct answer. -17.74. In the year 2005, what is the difference between the Savings(% of GNI) in Finland and Savings(% of GNI) in Nepal?
Your answer should be very brief. -15.28. In the year 2005, what is the difference between the Savings(% of GNI) of Finland and Savings(% of GNI) of Norway?
Ensure brevity in your answer.  -15.53. In the year 2005, what is the difference between the Savings(% of GNI) of Nepal and Savings(% of GNI) of Norway?
Give a very brief answer. -0.25. In the year 2006, what is the difference between the Savings(% of GNI) in Sub-Saharan Africa (all income levels) and Savings(% of GNI) in Finland?
Ensure brevity in your answer.  2.85. In the year 2006, what is the difference between the Savings(% of GNI) of Sub-Saharan Africa (all income levels) and Savings(% of GNI) of Nepal?
Give a very brief answer. -10.63. In the year 2006, what is the difference between the Savings(% of GNI) in Sub-Saharan Africa (all income levels) and Savings(% of GNI) in Norway?
Provide a succinct answer. -14.67. In the year 2006, what is the difference between the Savings(% of GNI) in Finland and Savings(% of GNI) in Nepal?
Provide a succinct answer. -13.48. In the year 2006, what is the difference between the Savings(% of GNI) of Finland and Savings(% of GNI) of Norway?
Offer a terse response. -17.52. In the year 2006, what is the difference between the Savings(% of GNI) in Nepal and Savings(% of GNI) in Norway?
Your answer should be very brief. -4.05. In the year 2007, what is the difference between the Savings(% of GNI) of Sub-Saharan Africa (all income levels) and Savings(% of GNI) of Finland?
Your answer should be very brief. -3.34. In the year 2007, what is the difference between the Savings(% of GNI) in Sub-Saharan Africa (all income levels) and Savings(% of GNI) in Nepal?
Provide a succinct answer. -15.73. In the year 2007, what is the difference between the Savings(% of GNI) of Sub-Saharan Africa (all income levels) and Savings(% of GNI) of Norway?
Your response must be concise. -17.75. In the year 2007, what is the difference between the Savings(% of GNI) of Finland and Savings(% of GNI) of Nepal?
Provide a short and direct response. -12.38. In the year 2007, what is the difference between the Savings(% of GNI) of Finland and Savings(% of GNI) of Norway?
Your answer should be very brief. -14.4. In the year 2007, what is the difference between the Savings(% of GNI) in Nepal and Savings(% of GNI) in Norway?
Provide a short and direct response. -2.02. In the year 2008, what is the difference between the Savings(% of GNI) in Sub-Saharan Africa (all income levels) and Savings(% of GNI) in Finland?
Your answer should be compact. 1.12. In the year 2008, what is the difference between the Savings(% of GNI) of Sub-Saharan Africa (all income levels) and Savings(% of GNI) of Nepal?
Your response must be concise. -19.24. In the year 2008, what is the difference between the Savings(% of GNI) in Sub-Saharan Africa (all income levels) and Savings(% of GNI) in Norway?
Offer a terse response. -17.93. In the year 2008, what is the difference between the Savings(% of GNI) of Finland and Savings(% of GNI) of Nepal?
Ensure brevity in your answer.  -20.36. In the year 2008, what is the difference between the Savings(% of GNI) of Finland and Savings(% of GNI) of Norway?
Your response must be concise. -19.05. In the year 2008, what is the difference between the Savings(% of GNI) of Nepal and Savings(% of GNI) of Norway?
Offer a very short reply. 1.31. In the year 2009, what is the difference between the Savings(% of GNI) in Sub-Saharan Africa (all income levels) and Savings(% of GNI) in Finland?
Keep it short and to the point. 2.12. In the year 2009, what is the difference between the Savings(% of GNI) in Sub-Saharan Africa (all income levels) and Savings(% of GNI) in Nepal?
Provide a short and direct response. -25.24. In the year 2009, what is the difference between the Savings(% of GNI) of Sub-Saharan Africa (all income levels) and Savings(% of GNI) of Norway?
Provide a succinct answer. -14.53. In the year 2009, what is the difference between the Savings(% of GNI) of Finland and Savings(% of GNI) of Nepal?
Ensure brevity in your answer.  -27.36. In the year 2009, what is the difference between the Savings(% of GNI) in Finland and Savings(% of GNI) in Norway?
Ensure brevity in your answer.  -16.65. In the year 2009, what is the difference between the Savings(% of GNI) of Nepal and Savings(% of GNI) of Norway?
Provide a short and direct response. 10.71. What is the ratio of the Savings(% of GNI) of Sub-Saharan Africa (all income levels) in 2002 to that in 2003?
Make the answer very short. 1.26. What is the ratio of the Savings(% of GNI) of Finland in 2002 to that in 2003?
Your answer should be very brief. 1.31. What is the ratio of the Savings(% of GNI) of Nepal in 2002 to that in 2003?
Offer a terse response. 0.98. What is the ratio of the Savings(% of GNI) of Norway in 2002 to that in 2003?
Offer a very short reply. 1.05. What is the ratio of the Savings(% of GNI) of Sub-Saharan Africa (all income levels) in 2002 to that in 2004?
Offer a terse response. 0.88. What is the ratio of the Savings(% of GNI) of Finland in 2002 to that in 2004?
Offer a very short reply. 1.14. What is the ratio of the Savings(% of GNI) of Nepal in 2002 to that in 2004?
Provide a succinct answer. 0.9. What is the ratio of the Savings(% of GNI) of Norway in 2002 to that in 2004?
Provide a short and direct response. 0.89. What is the ratio of the Savings(% of GNI) in Sub-Saharan Africa (all income levels) in 2002 to that in 2005?
Make the answer very short. 0.69. What is the ratio of the Savings(% of GNI) of Finland in 2002 to that in 2005?
Ensure brevity in your answer.  1.29. What is the ratio of the Savings(% of GNI) in Nepal in 2002 to that in 2005?
Your answer should be very brief. 0.81. What is the ratio of the Savings(% of GNI) in Norway in 2002 to that in 2005?
Your response must be concise. 0.71. What is the ratio of the Savings(% of GNI) in Sub-Saharan Africa (all income levels) in 2002 to that in 2006?
Your answer should be compact. 0.43. What is the ratio of the Savings(% of GNI) of Finland in 2002 to that in 2006?
Give a very brief answer. 1.28. What is the ratio of the Savings(% of GNI) of Nepal in 2002 to that in 2006?
Provide a succinct answer. 0.87. What is the ratio of the Savings(% of GNI) in Norway in 2002 to that in 2006?
Provide a succinct answer. 0.66. What is the ratio of the Savings(% of GNI) in Sub-Saharan Africa (all income levels) in 2002 to that in 2007?
Provide a succinct answer. 0.63. What is the ratio of the Savings(% of GNI) of Finland in 2002 to that in 2007?
Make the answer very short. 1.09. What is the ratio of the Savings(% of GNI) of Nepal in 2002 to that in 2007?
Your response must be concise. 0.84. What is the ratio of the Savings(% of GNI) in Norway in 2002 to that in 2007?
Keep it short and to the point. 0.69. What is the ratio of the Savings(% of GNI) of Sub-Saharan Africa (all income levels) in 2002 to that in 2008?
Your answer should be compact. 0.51. What is the ratio of the Savings(% of GNI) of Finland in 2002 to that in 2008?
Give a very brief answer. 1.34. What is the ratio of the Savings(% of GNI) of Nepal in 2002 to that in 2008?
Provide a short and direct response. 0.68. What is the ratio of the Savings(% of GNI) of Norway in 2002 to that in 2008?
Give a very brief answer. 0.63. What is the ratio of the Savings(% of GNI) in Sub-Saharan Africa (all income levels) in 2002 to that in 2009?
Your answer should be very brief. 0.94. What is the ratio of the Savings(% of GNI) of Finland in 2002 to that in 2009?
Provide a succinct answer. 3.41. What is the ratio of the Savings(% of GNI) in Nepal in 2002 to that in 2009?
Give a very brief answer. 0.67. What is the ratio of the Savings(% of GNI) of Norway in 2002 to that in 2009?
Provide a succinct answer. 0.9. What is the ratio of the Savings(% of GNI) in Sub-Saharan Africa (all income levels) in 2003 to that in 2004?
Keep it short and to the point. 0.7. What is the ratio of the Savings(% of GNI) in Finland in 2003 to that in 2004?
Your response must be concise. 0.87. What is the ratio of the Savings(% of GNI) in Nepal in 2003 to that in 2004?
Offer a very short reply. 0.92. What is the ratio of the Savings(% of GNI) in Norway in 2003 to that in 2004?
Give a very brief answer. 0.85. What is the ratio of the Savings(% of GNI) in Sub-Saharan Africa (all income levels) in 2003 to that in 2005?
Your answer should be very brief. 0.55. What is the ratio of the Savings(% of GNI) of Finland in 2003 to that in 2005?
Ensure brevity in your answer.  0.98. What is the ratio of the Savings(% of GNI) in Nepal in 2003 to that in 2005?
Your answer should be very brief. 0.83. What is the ratio of the Savings(% of GNI) of Norway in 2003 to that in 2005?
Provide a short and direct response. 0.68. What is the ratio of the Savings(% of GNI) of Sub-Saharan Africa (all income levels) in 2003 to that in 2006?
Offer a very short reply. 0.34. What is the ratio of the Savings(% of GNI) in Finland in 2003 to that in 2006?
Ensure brevity in your answer.  0.97. What is the ratio of the Savings(% of GNI) of Nepal in 2003 to that in 2006?
Your answer should be very brief. 0.88. What is the ratio of the Savings(% of GNI) of Norway in 2003 to that in 2006?
Keep it short and to the point. 0.63. What is the ratio of the Savings(% of GNI) of Sub-Saharan Africa (all income levels) in 2003 to that in 2007?
Your answer should be compact. 0.5. What is the ratio of the Savings(% of GNI) in Finland in 2003 to that in 2007?
Provide a succinct answer. 0.83. What is the ratio of the Savings(% of GNI) of Nepal in 2003 to that in 2007?
Offer a very short reply. 0.86. What is the ratio of the Savings(% of GNI) of Norway in 2003 to that in 2007?
Your response must be concise. 0.66. What is the ratio of the Savings(% of GNI) of Sub-Saharan Africa (all income levels) in 2003 to that in 2008?
Ensure brevity in your answer.  0.4. What is the ratio of the Savings(% of GNI) of Finland in 2003 to that in 2008?
Give a very brief answer. 1.02. What is the ratio of the Savings(% of GNI) in Nepal in 2003 to that in 2008?
Your answer should be compact. 0.7. What is the ratio of the Savings(% of GNI) in Norway in 2003 to that in 2008?
Give a very brief answer. 0.6. What is the ratio of the Savings(% of GNI) in Sub-Saharan Africa (all income levels) in 2003 to that in 2009?
Give a very brief answer. 0.75. What is the ratio of the Savings(% of GNI) in Finland in 2003 to that in 2009?
Offer a very short reply. 2.59. What is the ratio of the Savings(% of GNI) of Nepal in 2003 to that in 2009?
Offer a very short reply. 0.68. What is the ratio of the Savings(% of GNI) of Norway in 2003 to that in 2009?
Offer a very short reply. 0.85. What is the ratio of the Savings(% of GNI) of Sub-Saharan Africa (all income levels) in 2004 to that in 2005?
Offer a terse response. 0.79. What is the ratio of the Savings(% of GNI) in Finland in 2004 to that in 2005?
Offer a very short reply. 1.13. What is the ratio of the Savings(% of GNI) in Nepal in 2004 to that in 2005?
Offer a terse response. 0.9. What is the ratio of the Savings(% of GNI) in Norway in 2004 to that in 2005?
Provide a succinct answer. 0.8. What is the ratio of the Savings(% of GNI) in Sub-Saharan Africa (all income levels) in 2004 to that in 2006?
Make the answer very short. 0.48. What is the ratio of the Savings(% of GNI) in Finland in 2004 to that in 2006?
Your answer should be very brief. 1.12. What is the ratio of the Savings(% of GNI) in Nepal in 2004 to that in 2006?
Offer a terse response. 0.96. What is the ratio of the Savings(% of GNI) in Norway in 2004 to that in 2006?
Provide a succinct answer. 0.74. What is the ratio of the Savings(% of GNI) in Sub-Saharan Africa (all income levels) in 2004 to that in 2007?
Keep it short and to the point. 0.72. What is the ratio of the Savings(% of GNI) in Finland in 2004 to that in 2007?
Keep it short and to the point. 0.95. What is the ratio of the Savings(% of GNI) of Nepal in 2004 to that in 2007?
Make the answer very short. 0.94. What is the ratio of the Savings(% of GNI) in Norway in 2004 to that in 2007?
Make the answer very short. 0.78. What is the ratio of the Savings(% of GNI) in Sub-Saharan Africa (all income levels) in 2004 to that in 2008?
Ensure brevity in your answer.  0.58. What is the ratio of the Savings(% of GNI) in Finland in 2004 to that in 2008?
Provide a succinct answer. 1.17. What is the ratio of the Savings(% of GNI) of Nepal in 2004 to that in 2008?
Ensure brevity in your answer.  0.76. What is the ratio of the Savings(% of GNI) of Norway in 2004 to that in 2008?
Provide a short and direct response. 0.71. What is the ratio of the Savings(% of GNI) in Sub-Saharan Africa (all income levels) in 2004 to that in 2009?
Provide a succinct answer. 1.07. What is the ratio of the Savings(% of GNI) in Finland in 2004 to that in 2009?
Keep it short and to the point. 2.98. What is the ratio of the Savings(% of GNI) of Nepal in 2004 to that in 2009?
Your response must be concise. 0.74. What is the ratio of the Savings(% of GNI) in Sub-Saharan Africa (all income levels) in 2005 to that in 2006?
Ensure brevity in your answer.  0.62. What is the ratio of the Savings(% of GNI) of Nepal in 2005 to that in 2006?
Offer a terse response. 1.07. What is the ratio of the Savings(% of GNI) of Norway in 2005 to that in 2006?
Make the answer very short. 0.93. What is the ratio of the Savings(% of GNI) in Sub-Saharan Africa (all income levels) in 2005 to that in 2007?
Keep it short and to the point. 0.91. What is the ratio of the Savings(% of GNI) of Finland in 2005 to that in 2007?
Provide a short and direct response. 0.84. What is the ratio of the Savings(% of GNI) of Nepal in 2005 to that in 2007?
Your answer should be very brief. 1.04. What is the ratio of the Savings(% of GNI) in Norway in 2005 to that in 2007?
Provide a succinct answer. 0.97. What is the ratio of the Savings(% of GNI) in Sub-Saharan Africa (all income levels) in 2005 to that in 2008?
Your response must be concise. 0.74. What is the ratio of the Savings(% of GNI) in Finland in 2005 to that in 2008?
Ensure brevity in your answer.  1.04. What is the ratio of the Savings(% of GNI) in Nepal in 2005 to that in 2008?
Provide a short and direct response. 0.85. What is the ratio of the Savings(% of GNI) of Norway in 2005 to that in 2008?
Provide a short and direct response. 0.89. What is the ratio of the Savings(% of GNI) in Sub-Saharan Africa (all income levels) in 2005 to that in 2009?
Your answer should be very brief. 1.36. What is the ratio of the Savings(% of GNI) in Finland in 2005 to that in 2009?
Your answer should be compact. 2.64. What is the ratio of the Savings(% of GNI) in Nepal in 2005 to that in 2009?
Offer a terse response. 0.82. What is the ratio of the Savings(% of GNI) of Norway in 2005 to that in 2009?
Offer a terse response. 1.26. What is the ratio of the Savings(% of GNI) in Sub-Saharan Africa (all income levels) in 2006 to that in 2007?
Provide a succinct answer. 1.48. What is the ratio of the Savings(% of GNI) of Finland in 2006 to that in 2007?
Make the answer very short. 0.85. What is the ratio of the Savings(% of GNI) of Nepal in 2006 to that in 2007?
Offer a very short reply. 0.97. What is the ratio of the Savings(% of GNI) in Norway in 2006 to that in 2007?
Ensure brevity in your answer.  1.05. What is the ratio of the Savings(% of GNI) of Sub-Saharan Africa (all income levels) in 2006 to that in 2008?
Offer a terse response. 1.2. What is the ratio of the Savings(% of GNI) of Finland in 2006 to that in 2008?
Keep it short and to the point. 1.05. What is the ratio of the Savings(% of GNI) in Nepal in 2006 to that in 2008?
Keep it short and to the point. 0.79. What is the ratio of the Savings(% of GNI) of Sub-Saharan Africa (all income levels) in 2006 to that in 2009?
Give a very brief answer. 2.2. What is the ratio of the Savings(% of GNI) in Finland in 2006 to that in 2009?
Ensure brevity in your answer.  2.66. What is the ratio of the Savings(% of GNI) in Nepal in 2006 to that in 2009?
Ensure brevity in your answer.  0.77. What is the ratio of the Savings(% of GNI) in Norway in 2006 to that in 2009?
Offer a terse response. 1.36. What is the ratio of the Savings(% of GNI) in Sub-Saharan Africa (all income levels) in 2007 to that in 2008?
Provide a short and direct response. 0.81. What is the ratio of the Savings(% of GNI) in Finland in 2007 to that in 2008?
Provide a succinct answer. 1.23. What is the ratio of the Savings(% of GNI) of Nepal in 2007 to that in 2008?
Keep it short and to the point. 0.81. What is the ratio of the Savings(% of GNI) in Norway in 2007 to that in 2008?
Provide a short and direct response. 0.92. What is the ratio of the Savings(% of GNI) in Sub-Saharan Africa (all income levels) in 2007 to that in 2009?
Provide a succinct answer. 1.49. What is the ratio of the Savings(% of GNI) in Finland in 2007 to that in 2009?
Your response must be concise. 3.13. What is the ratio of the Savings(% of GNI) in Nepal in 2007 to that in 2009?
Provide a short and direct response. 0.79. What is the ratio of the Savings(% of GNI) in Norway in 2007 to that in 2009?
Ensure brevity in your answer.  1.3. What is the ratio of the Savings(% of GNI) of Sub-Saharan Africa (all income levels) in 2008 to that in 2009?
Ensure brevity in your answer.  1.84. What is the ratio of the Savings(% of GNI) of Finland in 2008 to that in 2009?
Your response must be concise. 2.54. What is the ratio of the Savings(% of GNI) of Nepal in 2008 to that in 2009?
Offer a terse response. 0.97. What is the ratio of the Savings(% of GNI) in Norway in 2008 to that in 2009?
Offer a terse response. 1.41. What is the difference between the highest and the second highest Savings(% of GNI) of Sub-Saharan Africa (all income levels)?
Offer a terse response. 2.21. What is the difference between the highest and the second highest Savings(% of GNI) in Finland?
Provide a succinct answer. 1.11. What is the difference between the highest and the second highest Savings(% of GNI) of Nepal?
Your answer should be compact. 0.86. What is the difference between the highest and the second highest Savings(% of GNI) in Norway?
Your answer should be very brief. 1.04. What is the difference between the highest and the lowest Savings(% of GNI) in Sub-Saharan Africa (all income levels)?
Offer a terse response. 8.91. What is the difference between the highest and the lowest Savings(% of GNI) of Finland?
Provide a short and direct response. 9.59. What is the difference between the highest and the lowest Savings(% of GNI) of Nepal?
Offer a very short reply. 10.48. What is the difference between the highest and the lowest Savings(% of GNI) in Norway?
Offer a terse response. 11.58. 